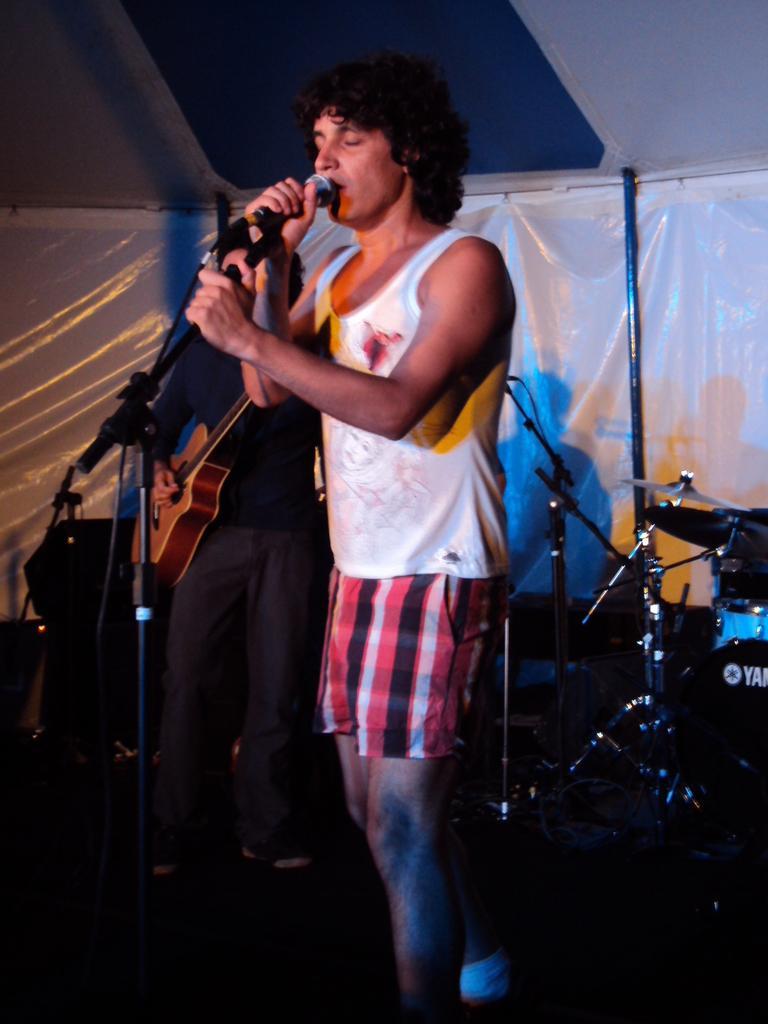Please provide a concise description of this image. In this picture we can see a man who is standing in front of mike. Here we can see a man playing guitar. These are some musical instruments. On the background there is a banner. 